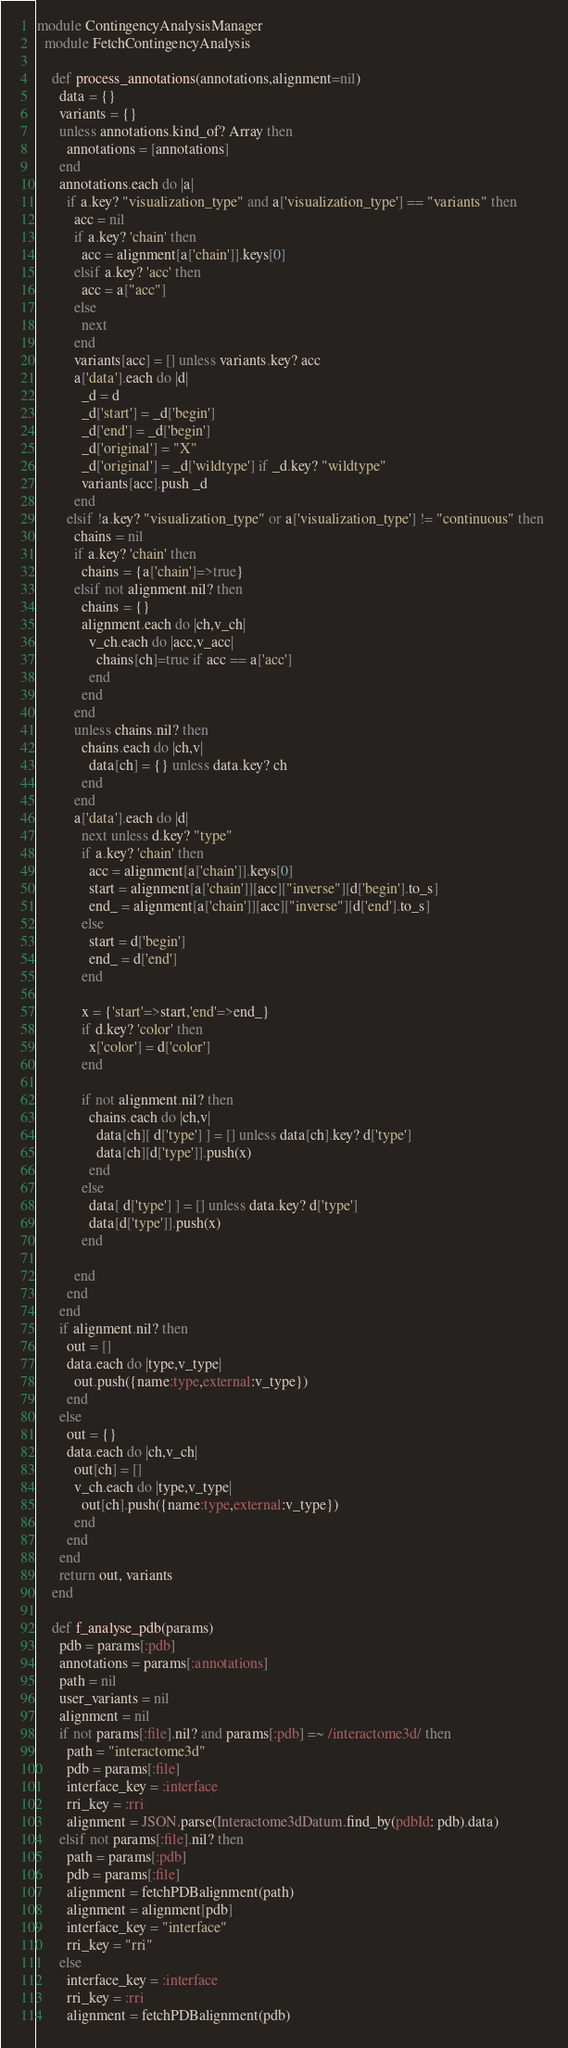<code> <loc_0><loc_0><loc_500><loc_500><_Ruby_>module ContingencyAnalysisManager
  module FetchContingencyAnalysis

    def process_annotations(annotations,alignment=nil)
      data = {}
      variants = {}
      unless annotations.kind_of? Array then
        annotations = [annotations]
      end
      annotations.each do |a|
        if a.key? "visualization_type" and a['visualization_type'] == "variants" then
          acc = nil
          if a.key? 'chain' then
            acc = alignment[a['chain']].keys[0]
          elsif a.key? 'acc' then
            acc = a["acc"]
          else
            next
          end
          variants[acc] = [] unless variants.key? acc
          a['data'].each do |d|
            _d = d
            _d['start'] = _d['begin']
            _d['end'] = _d['begin']
            _d['original'] = "X"
            _d['original'] = _d['wildtype'] if _d.key? "wildtype"
            variants[acc].push _d
          end
        elsif !a.key? "visualization_type" or a['visualization_type'] != "continuous" then 
          chains = nil
          if a.key? 'chain' then
            chains = {a['chain']=>true}
          elsif not alignment.nil? then
            chains = {}
            alignment.each do |ch,v_ch|
              v_ch.each do |acc,v_acc|
                chains[ch]=true if acc == a['acc']
              end
            end
          end
          unless chains.nil? then
            chains.each do |ch,v|
              data[ch] = {} unless data.key? ch
            end
          end
          a['data'].each do |d|
            next unless d.key? "type"
            if a.key? 'chain' then
              acc = alignment[a['chain']].keys[0]    
              start = alignment[a['chain']][acc]["inverse"][d['begin'].to_s]
              end_ = alignment[a['chain']][acc]["inverse"][d['end'].to_s]
            else
              start = d['begin']
              end_ = d['end']
            end

            x = {'start'=>start,'end'=>end_}
            if d.key? 'color' then
              x['color'] = d['color']
            end

            if not alignment.nil? then
              chains.each do |ch,v|
                data[ch][ d['type'] ] = [] unless data[ch].key? d['type']
                data[ch][d['type']].push(x)
              end
            else
              data[ d['type'] ] = [] unless data.key? d['type'] 
              data[d['type']].push(x)
            end

          end
        end
      end
      if alignment.nil? then
        out = []
        data.each do |type,v_type|
          out.push({name:type,external:v_type})
        end       
      else
        out = {}
        data.each do |ch,v_ch|
          out[ch] = []
          v_ch.each do |type,v_type|
            out[ch].push({name:type,external:v_type})
          end
        end
      end
      return out, variants
    end

    def f_analyse_pdb(params)
      pdb = params[:pdb]
      annotations = params[:annotations]
      path = nil
      user_variants = nil
      alignment = nil
      if not params[:file].nil? and params[:pdb] =~ /interactome3d/ then
        path = "interactome3d"
        pdb = params[:file]
        interface_key = :interface
        rri_key = :rri
        alignment = JSON.parse(Interactome3dDatum.find_by(pdbId: pdb).data)
      elsif not params[:file].nil? then
        path = params[:pdb]
        pdb = params[:file]
        alignment = fetchPDBalignment(path)
        alignment = alignment[pdb]
        interface_key = "interface"
        rri_key = "rri"
      else
        interface_key = :interface
        rri_key = :rri
        alignment = fetchPDBalignment(pdb)</code> 